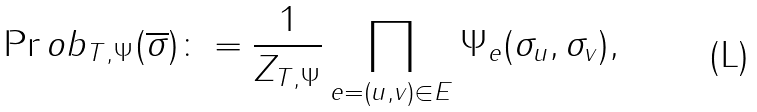<formula> <loc_0><loc_0><loc_500><loc_500>\Pr o b _ { T , \Psi } ( \overline { \sigma } ) \colon = \frac { 1 } { Z _ { T , \Psi } } \prod _ { e = ( u , v ) \in E } \Psi _ { e } ( \sigma _ { u } , \sigma _ { v } ) ,</formula> 